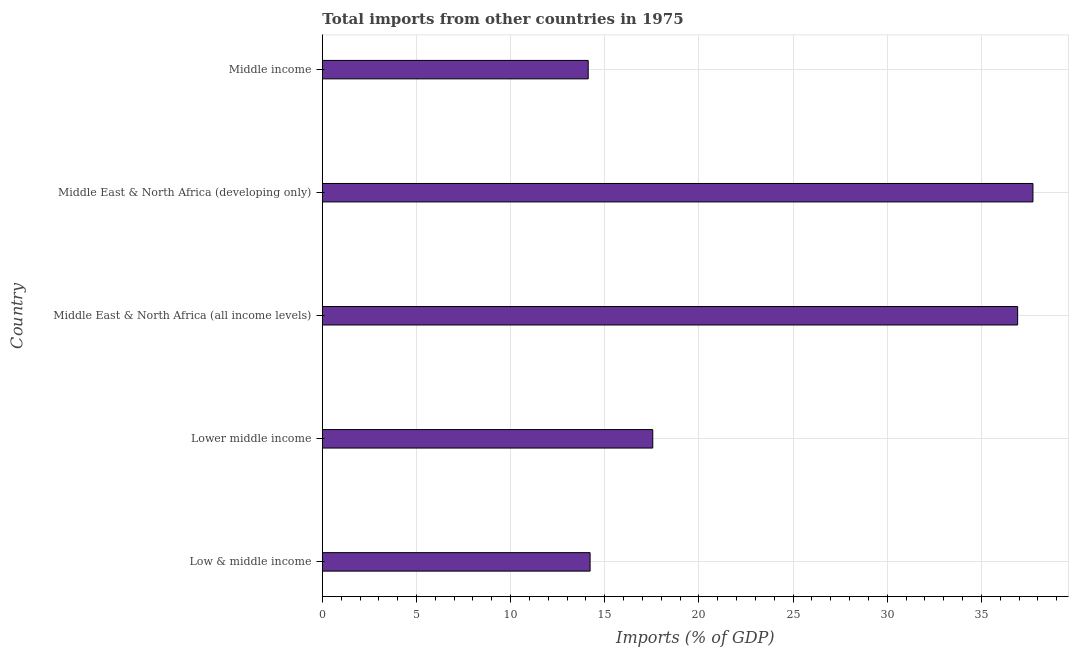Does the graph contain any zero values?
Ensure brevity in your answer.  No. Does the graph contain grids?
Give a very brief answer. Yes. What is the title of the graph?
Provide a short and direct response. Total imports from other countries in 1975. What is the label or title of the X-axis?
Your response must be concise. Imports (% of GDP). What is the total imports in Middle income?
Give a very brief answer. 14.12. Across all countries, what is the maximum total imports?
Provide a succinct answer. 37.73. Across all countries, what is the minimum total imports?
Keep it short and to the point. 14.12. In which country was the total imports maximum?
Ensure brevity in your answer.  Middle East & North Africa (developing only). What is the sum of the total imports?
Offer a very short reply. 120.54. What is the difference between the total imports in Middle East & North Africa (all income levels) and Middle income?
Provide a short and direct response. 22.8. What is the average total imports per country?
Give a very brief answer. 24.11. What is the median total imports?
Provide a succinct answer. 17.55. What is the ratio of the total imports in Middle East & North Africa (all income levels) to that in Middle income?
Keep it short and to the point. 2.62. Is the total imports in Middle East & North Africa (all income levels) less than that in Middle East & North Africa (developing only)?
Your answer should be compact. Yes. Is the difference between the total imports in Lower middle income and Middle East & North Africa (developing only) greater than the difference between any two countries?
Your answer should be compact. No. What is the difference between the highest and the second highest total imports?
Ensure brevity in your answer.  0.81. Is the sum of the total imports in Middle East & North Africa (all income levels) and Middle East & North Africa (developing only) greater than the maximum total imports across all countries?
Your answer should be very brief. Yes. What is the difference between the highest and the lowest total imports?
Keep it short and to the point. 23.62. How many bars are there?
Keep it short and to the point. 5. Are all the bars in the graph horizontal?
Make the answer very short. Yes. What is the Imports (% of GDP) in Low & middle income?
Give a very brief answer. 14.22. What is the Imports (% of GDP) in Lower middle income?
Provide a short and direct response. 17.55. What is the Imports (% of GDP) in Middle East & North Africa (all income levels)?
Provide a succinct answer. 36.92. What is the Imports (% of GDP) in Middle East & North Africa (developing only)?
Make the answer very short. 37.73. What is the Imports (% of GDP) in Middle income?
Make the answer very short. 14.12. What is the difference between the Imports (% of GDP) in Low & middle income and Lower middle income?
Your answer should be compact. -3.33. What is the difference between the Imports (% of GDP) in Low & middle income and Middle East & North Africa (all income levels)?
Your answer should be compact. -22.7. What is the difference between the Imports (% of GDP) in Low & middle income and Middle East & North Africa (developing only)?
Offer a very short reply. -23.52. What is the difference between the Imports (% of GDP) in Low & middle income and Middle income?
Ensure brevity in your answer.  0.1. What is the difference between the Imports (% of GDP) in Lower middle income and Middle East & North Africa (all income levels)?
Keep it short and to the point. -19.38. What is the difference between the Imports (% of GDP) in Lower middle income and Middle East & North Africa (developing only)?
Provide a short and direct response. -20.19. What is the difference between the Imports (% of GDP) in Lower middle income and Middle income?
Keep it short and to the point. 3.43. What is the difference between the Imports (% of GDP) in Middle East & North Africa (all income levels) and Middle East & North Africa (developing only)?
Keep it short and to the point. -0.81. What is the difference between the Imports (% of GDP) in Middle East & North Africa (all income levels) and Middle income?
Offer a terse response. 22.8. What is the difference between the Imports (% of GDP) in Middle East & North Africa (developing only) and Middle income?
Give a very brief answer. 23.62. What is the ratio of the Imports (% of GDP) in Low & middle income to that in Lower middle income?
Give a very brief answer. 0.81. What is the ratio of the Imports (% of GDP) in Low & middle income to that in Middle East & North Africa (all income levels)?
Offer a terse response. 0.39. What is the ratio of the Imports (% of GDP) in Low & middle income to that in Middle East & North Africa (developing only)?
Your answer should be compact. 0.38. What is the ratio of the Imports (% of GDP) in Low & middle income to that in Middle income?
Make the answer very short. 1.01. What is the ratio of the Imports (% of GDP) in Lower middle income to that in Middle East & North Africa (all income levels)?
Your response must be concise. 0.47. What is the ratio of the Imports (% of GDP) in Lower middle income to that in Middle East & North Africa (developing only)?
Offer a terse response. 0.47. What is the ratio of the Imports (% of GDP) in Lower middle income to that in Middle income?
Provide a short and direct response. 1.24. What is the ratio of the Imports (% of GDP) in Middle East & North Africa (all income levels) to that in Middle income?
Ensure brevity in your answer.  2.62. What is the ratio of the Imports (% of GDP) in Middle East & North Africa (developing only) to that in Middle income?
Provide a succinct answer. 2.67. 